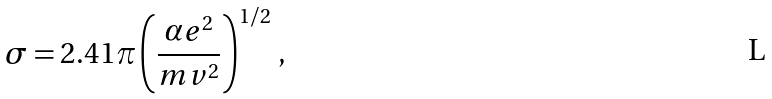Convert formula to latex. <formula><loc_0><loc_0><loc_500><loc_500>\sigma = 2 . 4 1 \pi \left ( \frac { \alpha e ^ { 2 } } { m v ^ { 2 } } \right ) ^ { 1 / 2 } \, ,</formula> 